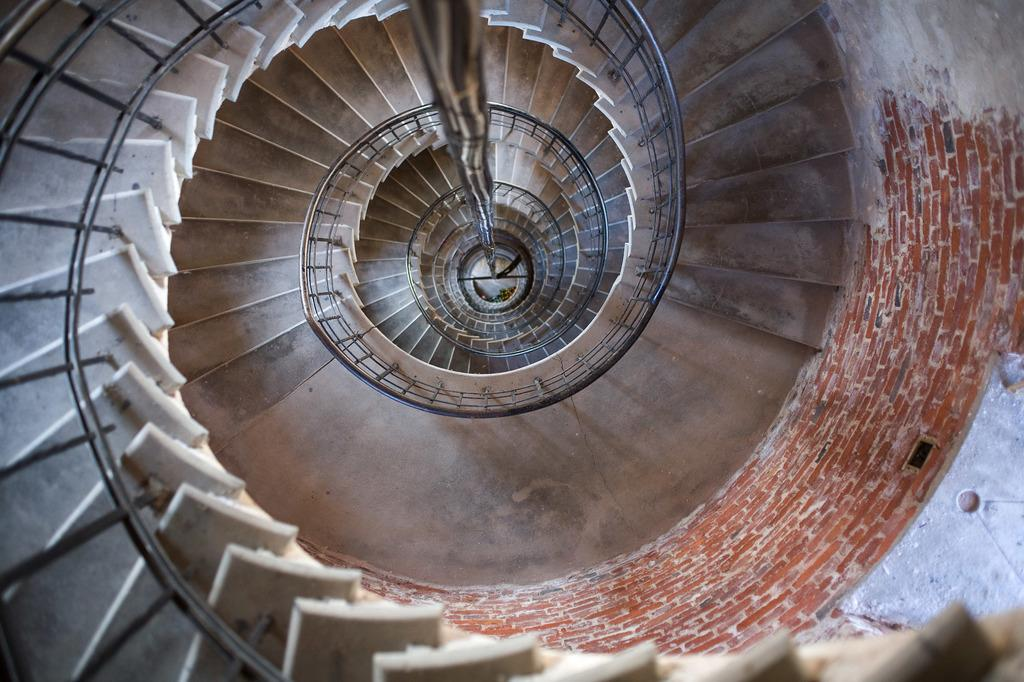What type of structure is present in the image? There is a staircase in the image. What feature is associated with the staircase? There is a handrail associated with the staircase. What other object can be seen in the image? There is a pole in the image. What is located on the right side of the image? There is a wall on the right side of the image. How many vests are hanging on the wall in the image? There are no vests present in the image. What type of furniture can be seen in the bedroom in the image? There is no bedroom or furniture present in the image. 